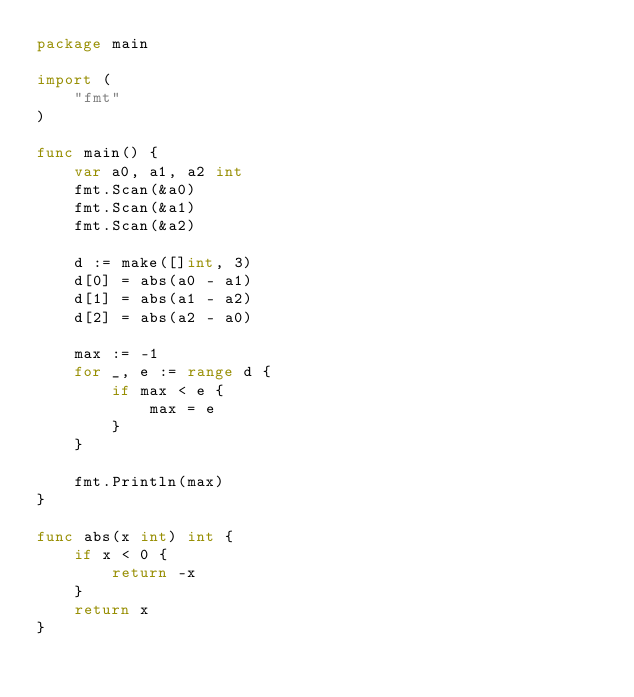<code> <loc_0><loc_0><loc_500><loc_500><_Go_>package main

import (
    "fmt"
)

func main() {
	var a0, a1, a2 int
	fmt.Scan(&a0)
	fmt.Scan(&a1)
	fmt.Scan(&a2)
	
	d := make([]int, 3)
	d[0] = abs(a0 - a1)
	d[1] = abs(a1 - a2)
	d[2] = abs(a2 - a0)
	
	max := -1
	for _, e := range d {
		if max < e {
			max = e
		}
	}
	
	fmt.Println(max)
}

func abs(x int) int {
	if x < 0 {
		return -x
	}
	return x
}</code> 